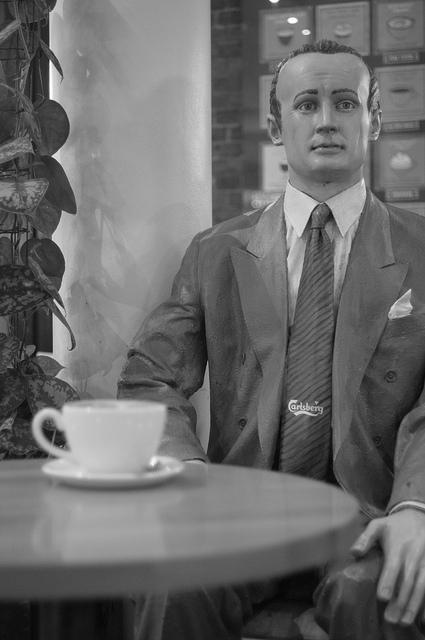What is on the table?
Be succinct. Cup. Is there a design on the tie?
Quick response, please. Yes. Is the man real or fake?
Give a very brief answer. Fake. 